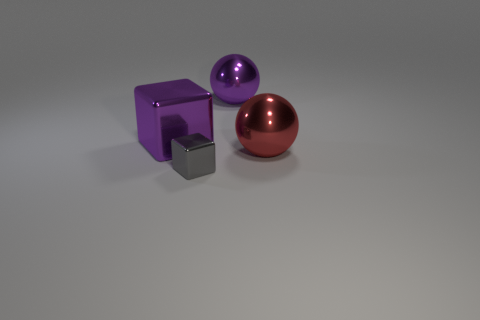Add 2 small gray cubes. How many objects exist? 6 Subtract all purple blocks. How many blocks are left? 1 Add 2 large cubes. How many large cubes exist? 3 Subtract 0 brown cubes. How many objects are left? 4 Subtract all purple blocks. Subtract all blue balls. How many blocks are left? 1 Subtract all purple shiny blocks. Subtract all purple metal things. How many objects are left? 1 Add 1 big metal spheres. How many big metal spheres are left? 3 